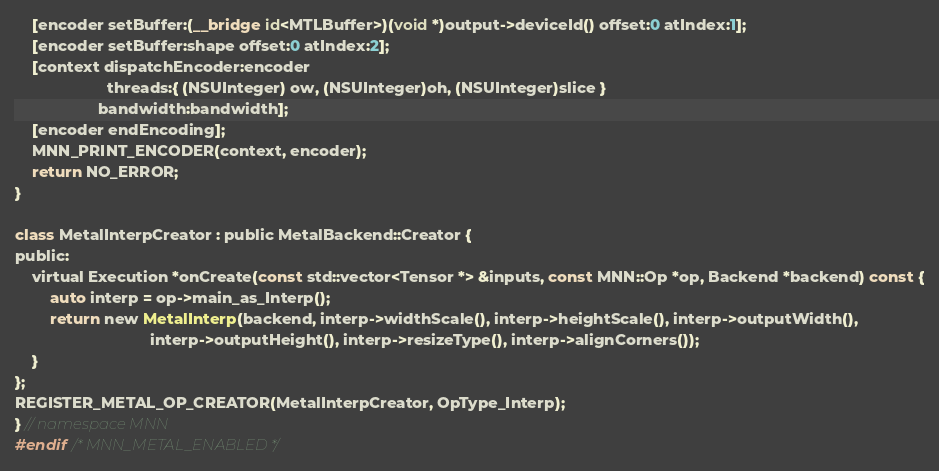<code> <loc_0><loc_0><loc_500><loc_500><_ObjectiveC_>    [encoder setBuffer:(__bridge id<MTLBuffer>)(void *)output->deviceId() offset:0 atIndex:1];
    [encoder setBuffer:shape offset:0 atIndex:2];
    [context dispatchEncoder:encoder
                     threads:{ (NSUInteger) ow, (NSUInteger)oh, (NSUInteger)slice }
                   bandwidth:bandwidth];
    [encoder endEncoding];
    MNN_PRINT_ENCODER(context, encoder);
    return NO_ERROR;
}

class MetalInterpCreator : public MetalBackend::Creator {
public:
    virtual Execution *onCreate(const std::vector<Tensor *> &inputs, const MNN::Op *op, Backend *backend) const {
        auto interp = op->main_as_Interp();
        return new MetalInterp(backend, interp->widthScale(), interp->heightScale(), interp->outputWidth(),
                               interp->outputHeight(), interp->resizeType(), interp->alignCorners());
    }
};
REGISTER_METAL_OP_CREATOR(MetalInterpCreator, OpType_Interp);
} // namespace MNN
#endif /* MNN_METAL_ENABLED */
</code> 